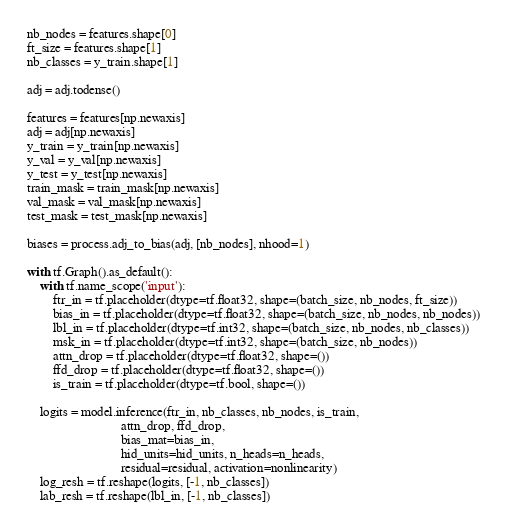Convert code to text. <code><loc_0><loc_0><loc_500><loc_500><_Python_>nb_nodes = features.shape[0]
ft_size = features.shape[1]
nb_classes = y_train.shape[1]

adj = adj.todense()

features = features[np.newaxis]
adj = adj[np.newaxis]
y_train = y_train[np.newaxis]
y_val = y_val[np.newaxis]
y_test = y_test[np.newaxis]
train_mask = train_mask[np.newaxis]
val_mask = val_mask[np.newaxis]
test_mask = test_mask[np.newaxis]

biases = process.adj_to_bias(adj, [nb_nodes], nhood=1)

with tf.Graph().as_default():
    with tf.name_scope('input'):
        ftr_in = tf.placeholder(dtype=tf.float32, shape=(batch_size, nb_nodes, ft_size))
        bias_in = tf.placeholder(dtype=tf.float32, shape=(batch_size, nb_nodes, nb_nodes))
        lbl_in = tf.placeholder(dtype=tf.int32, shape=(batch_size, nb_nodes, nb_classes))
        msk_in = tf.placeholder(dtype=tf.int32, shape=(batch_size, nb_nodes))
        attn_drop = tf.placeholder(dtype=tf.float32, shape=())
        ffd_drop = tf.placeholder(dtype=tf.float32, shape=())
        is_train = tf.placeholder(dtype=tf.bool, shape=())

    logits = model.inference(ftr_in, nb_classes, nb_nodes, is_train,
                             attn_drop, ffd_drop,
                             bias_mat=bias_in,
                             hid_units=hid_units, n_heads=n_heads,
                             residual=residual, activation=nonlinearity)
    log_resh = tf.reshape(logits, [-1, nb_classes])
    lab_resh = tf.reshape(lbl_in, [-1, nb_classes])</code> 